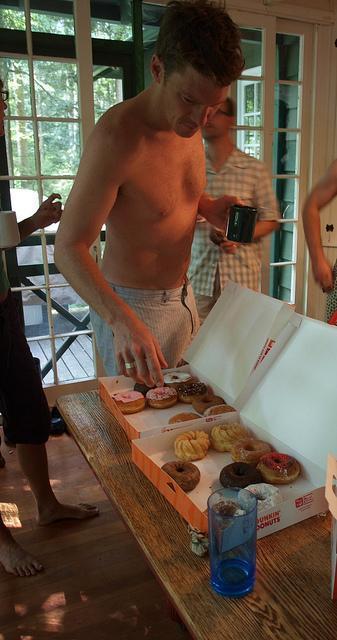How many cups are there?
Give a very brief answer. 1. How many people are there?
Give a very brief answer. 4. How many kites are there?
Give a very brief answer. 0. 